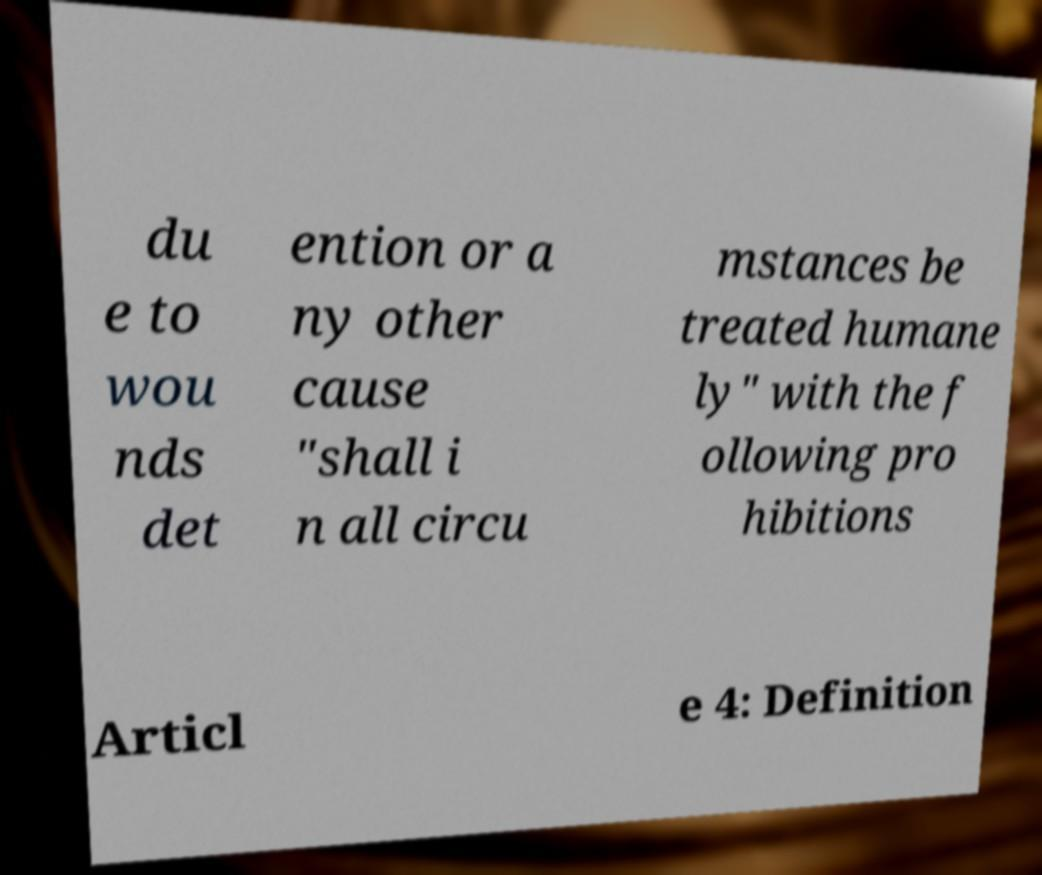There's text embedded in this image that I need extracted. Can you transcribe it verbatim? du e to wou nds det ention or a ny other cause "shall i n all circu mstances be treated humane ly" with the f ollowing pro hibitions Articl e 4: Definition 